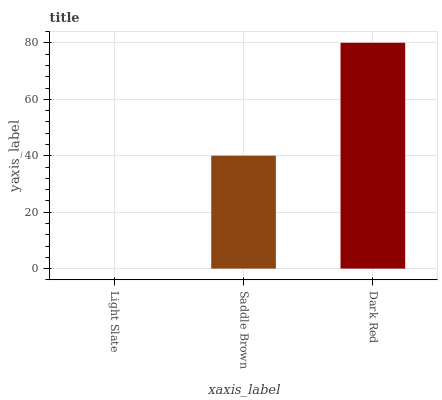Is Light Slate the minimum?
Answer yes or no. Yes. Is Dark Red the maximum?
Answer yes or no. Yes. Is Saddle Brown the minimum?
Answer yes or no. No. Is Saddle Brown the maximum?
Answer yes or no. No. Is Saddle Brown greater than Light Slate?
Answer yes or no. Yes. Is Light Slate less than Saddle Brown?
Answer yes or no. Yes. Is Light Slate greater than Saddle Brown?
Answer yes or no. No. Is Saddle Brown less than Light Slate?
Answer yes or no. No. Is Saddle Brown the high median?
Answer yes or no. Yes. Is Saddle Brown the low median?
Answer yes or no. Yes. Is Light Slate the high median?
Answer yes or no. No. Is Dark Red the low median?
Answer yes or no. No. 